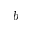<formula> <loc_0><loc_0><loc_500><loc_500>b</formula> 